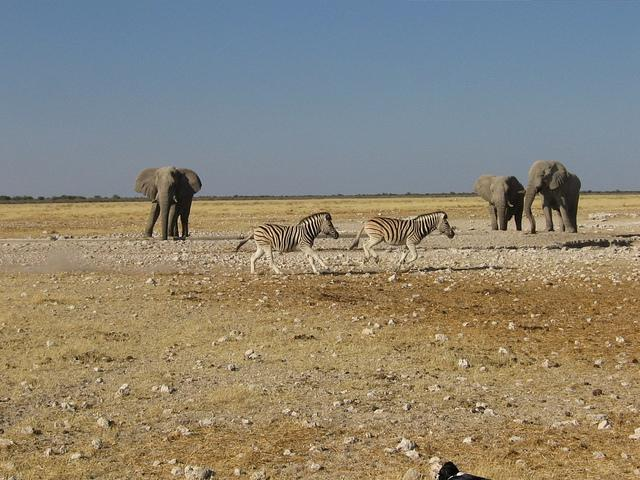How many zebras are running across the rocky field? Please explain your reasoning. two. Two zebras are chasing each other. 